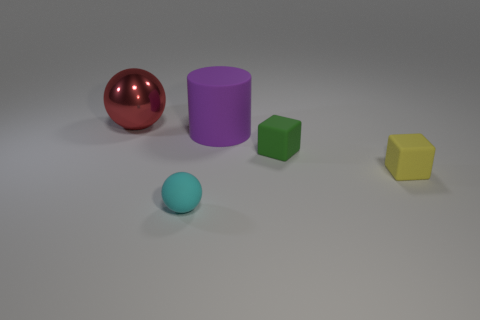There is a cylinder that is made of the same material as the tiny sphere; what is its color?
Provide a short and direct response. Purple. There is a tiny block that is behind the tiny cube in front of the tiny green matte thing; what number of purple rubber cylinders are to the right of it?
Make the answer very short. 0. Is there anything else that is the same shape as the large metal thing?
Give a very brief answer. Yes. What number of objects are either matte objects that are on the right side of the cyan object or rubber cylinders?
Give a very brief answer. 3. There is a big object to the left of the big matte thing; is it the same color as the small rubber ball?
Offer a terse response. No. The metal object behind the sphere that is in front of the metal sphere is what shape?
Offer a very short reply. Sphere. Are there fewer shiny objects that are to the right of the purple rubber cylinder than purple rubber things behind the red sphere?
Keep it short and to the point. No. The other object that is the same shape as the big red metal object is what size?
Keep it short and to the point. Small. Is there anything else that has the same size as the purple thing?
Your answer should be very brief. Yes. How many things are either matte objects that are to the left of the green rubber block or matte objects that are right of the small cyan thing?
Provide a succinct answer. 4. 